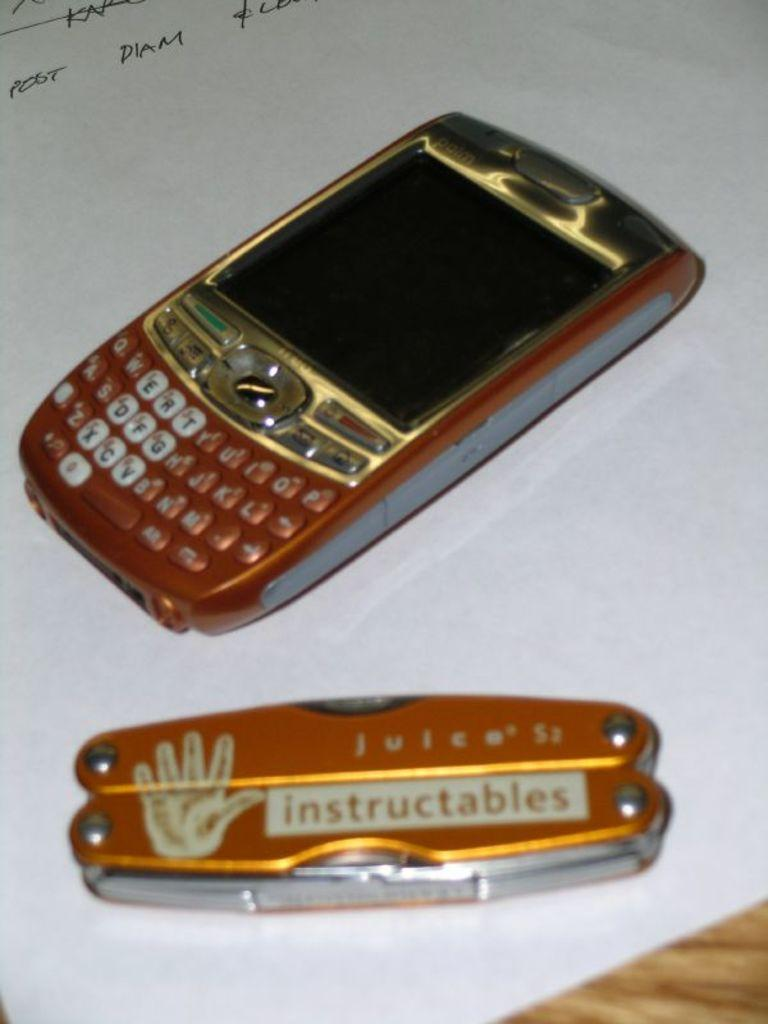<image>
Present a compact description of the photo's key features. The Instructables pocket knife colors match the colors of the nearby cell phone. 